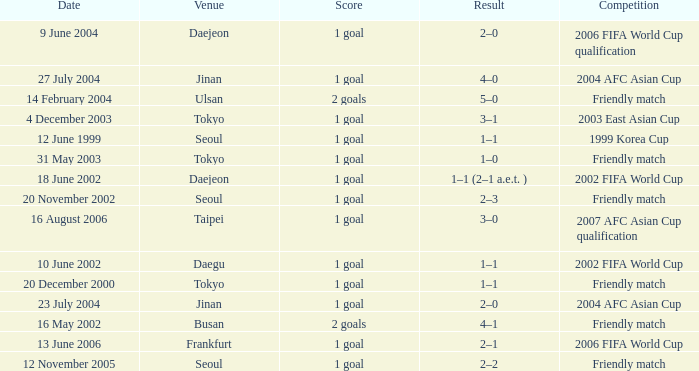What is the competition that occured on 27 July 2004? 2004 AFC Asian Cup. 